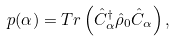Convert formula to latex. <formula><loc_0><loc_0><loc_500><loc_500>p ( \alpha ) = T r \left ( \hat { C } _ { \alpha } ^ { \dagger } \hat { \rho } _ { 0 } \hat { C } _ { \alpha } \right ) ,</formula> 